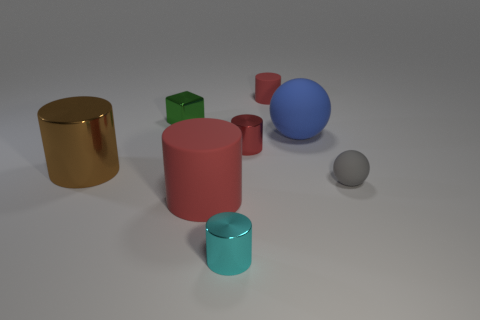Subtract all brown metal cylinders. How many cylinders are left? 4 Add 1 tiny matte cylinders. How many objects exist? 9 Subtract all gray balls. How many balls are left? 1 Add 6 red metal cylinders. How many red metal cylinders are left? 7 Add 7 small rubber spheres. How many small rubber spheres exist? 8 Subtract 0 purple balls. How many objects are left? 8 Subtract all cylinders. How many objects are left? 3 Subtract 1 blocks. How many blocks are left? 0 Subtract all yellow cylinders. Subtract all purple cubes. How many cylinders are left? 5 Subtract all green cylinders. How many gray spheres are left? 1 